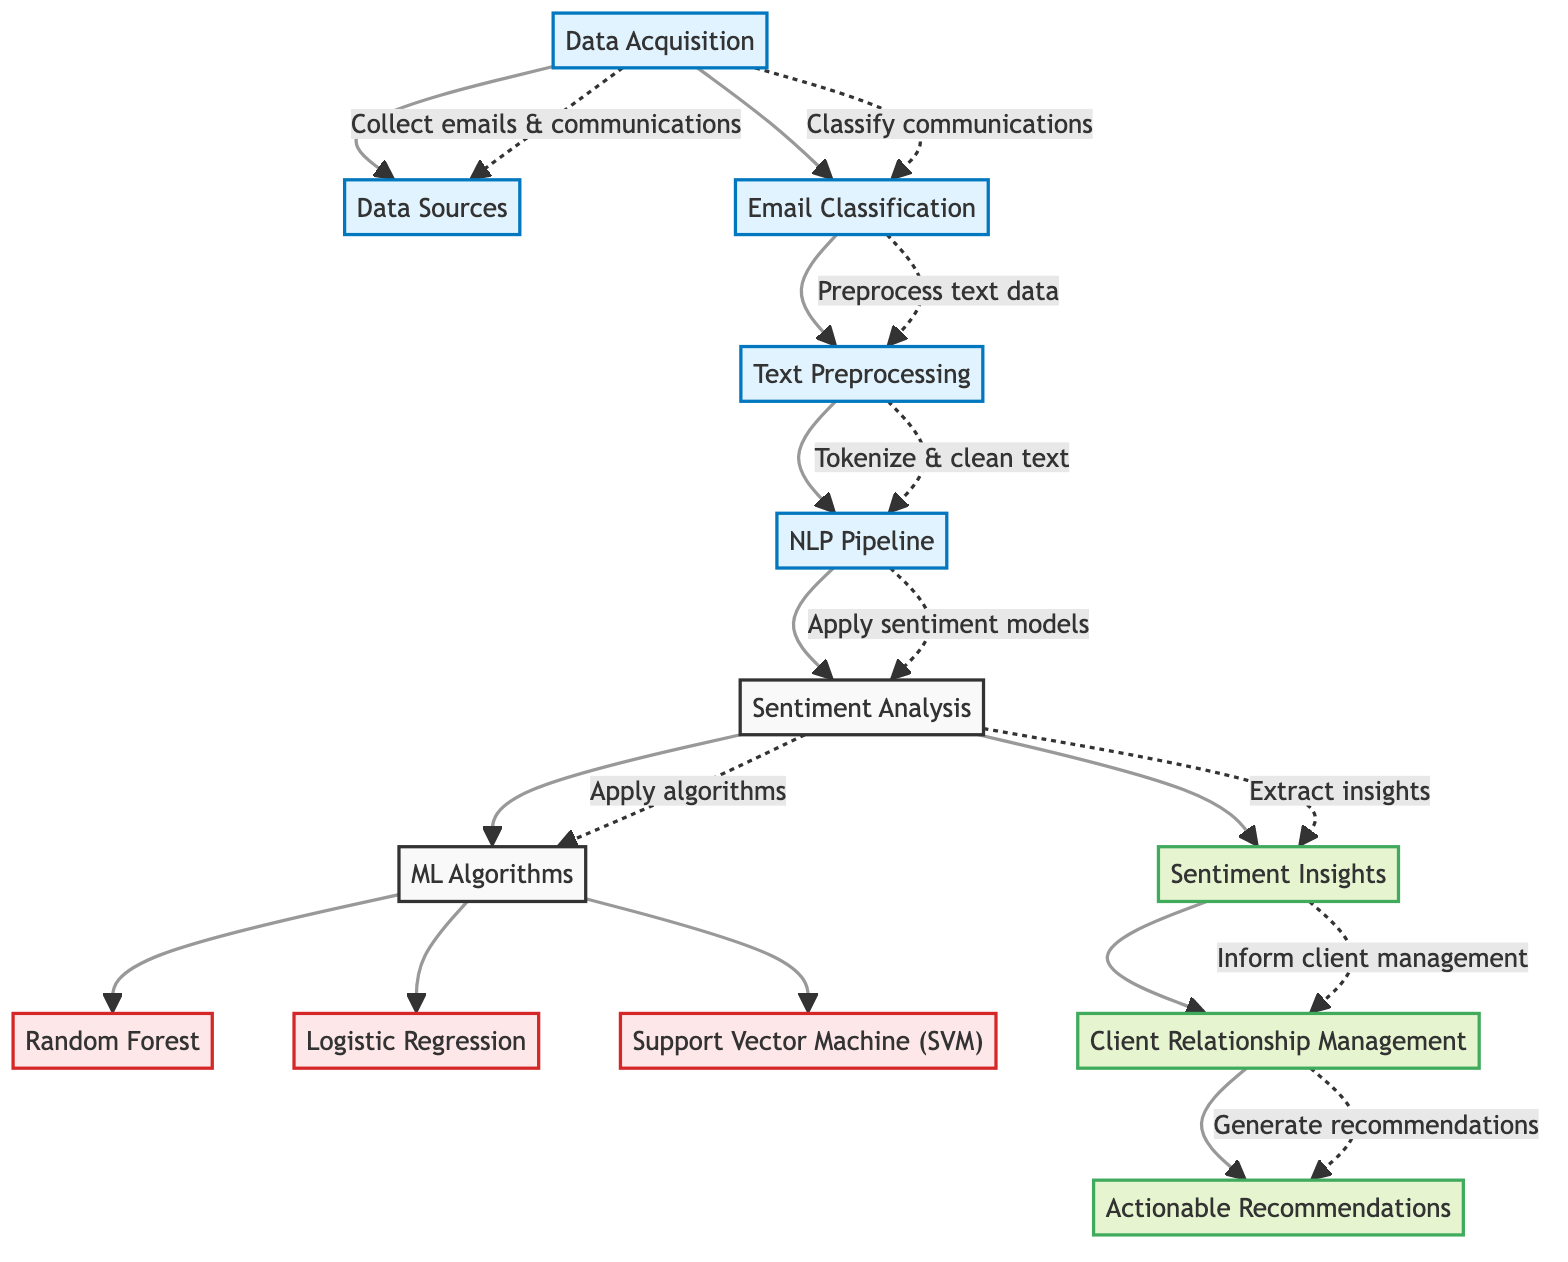What is the first step in the process? The diagram starts with the "Data Acquisition" step as the entry point of the flowchart.
Answer: Data Acquisition How many ML algorithms are listed in the diagram? There are three ML algorithms noted in the diagram: Random Forest, Logistic Regression, and Support Vector Machine. They are connected to the sentiment analysis step, thus counting gives us a total of three distinct algorithms.
Answer: Three What transformation occurs after "Text Preprocessing"? After the "Text Preprocessing" step, the next transformation is the "NLP Pipeline," which processes the text that has been cleaned and tokenized for analysis.
Answer: NLP Pipeline Which step provides insights to improve client relations? The "Sentiment Insights" step is the specific output that provides analysis results to inform and enhance client relationships based on the sentiment of communications.
Answer: Sentiment Insights What follows "Sentiment Analysis" in the flow of processes? Following "Sentiment Analysis," the next step in the diagram is "ML Algorithms," indicating that several machine learning methods are applied to analyze the sentiment results obtained.
Answer: ML Algorithms What is the final output of the diagram? The final outcome after the series of processes illustrated in the diagram culminates in "Actionable Recommendations," which summarizes the insights to develop strategies for client management.
Answer: Actionable Recommendations How are emails initially processed according to the diagram? Emails are first categorized in the "Email Classification" step, which involves classifying the communications to facilitate key preprocessing and analysis.
Answer: Email Classification Which algorithm is associated with the "Sendiment Analysis" process? The algorithms associated with the sentiment analysis process include Random Forest, Logistic Regression, and Support Vector Machine. The diagram indicates all three algorithms derive output from the sentiment analysis step.
Answer: Random Forest, Logistic Regression, Support Vector Machine 